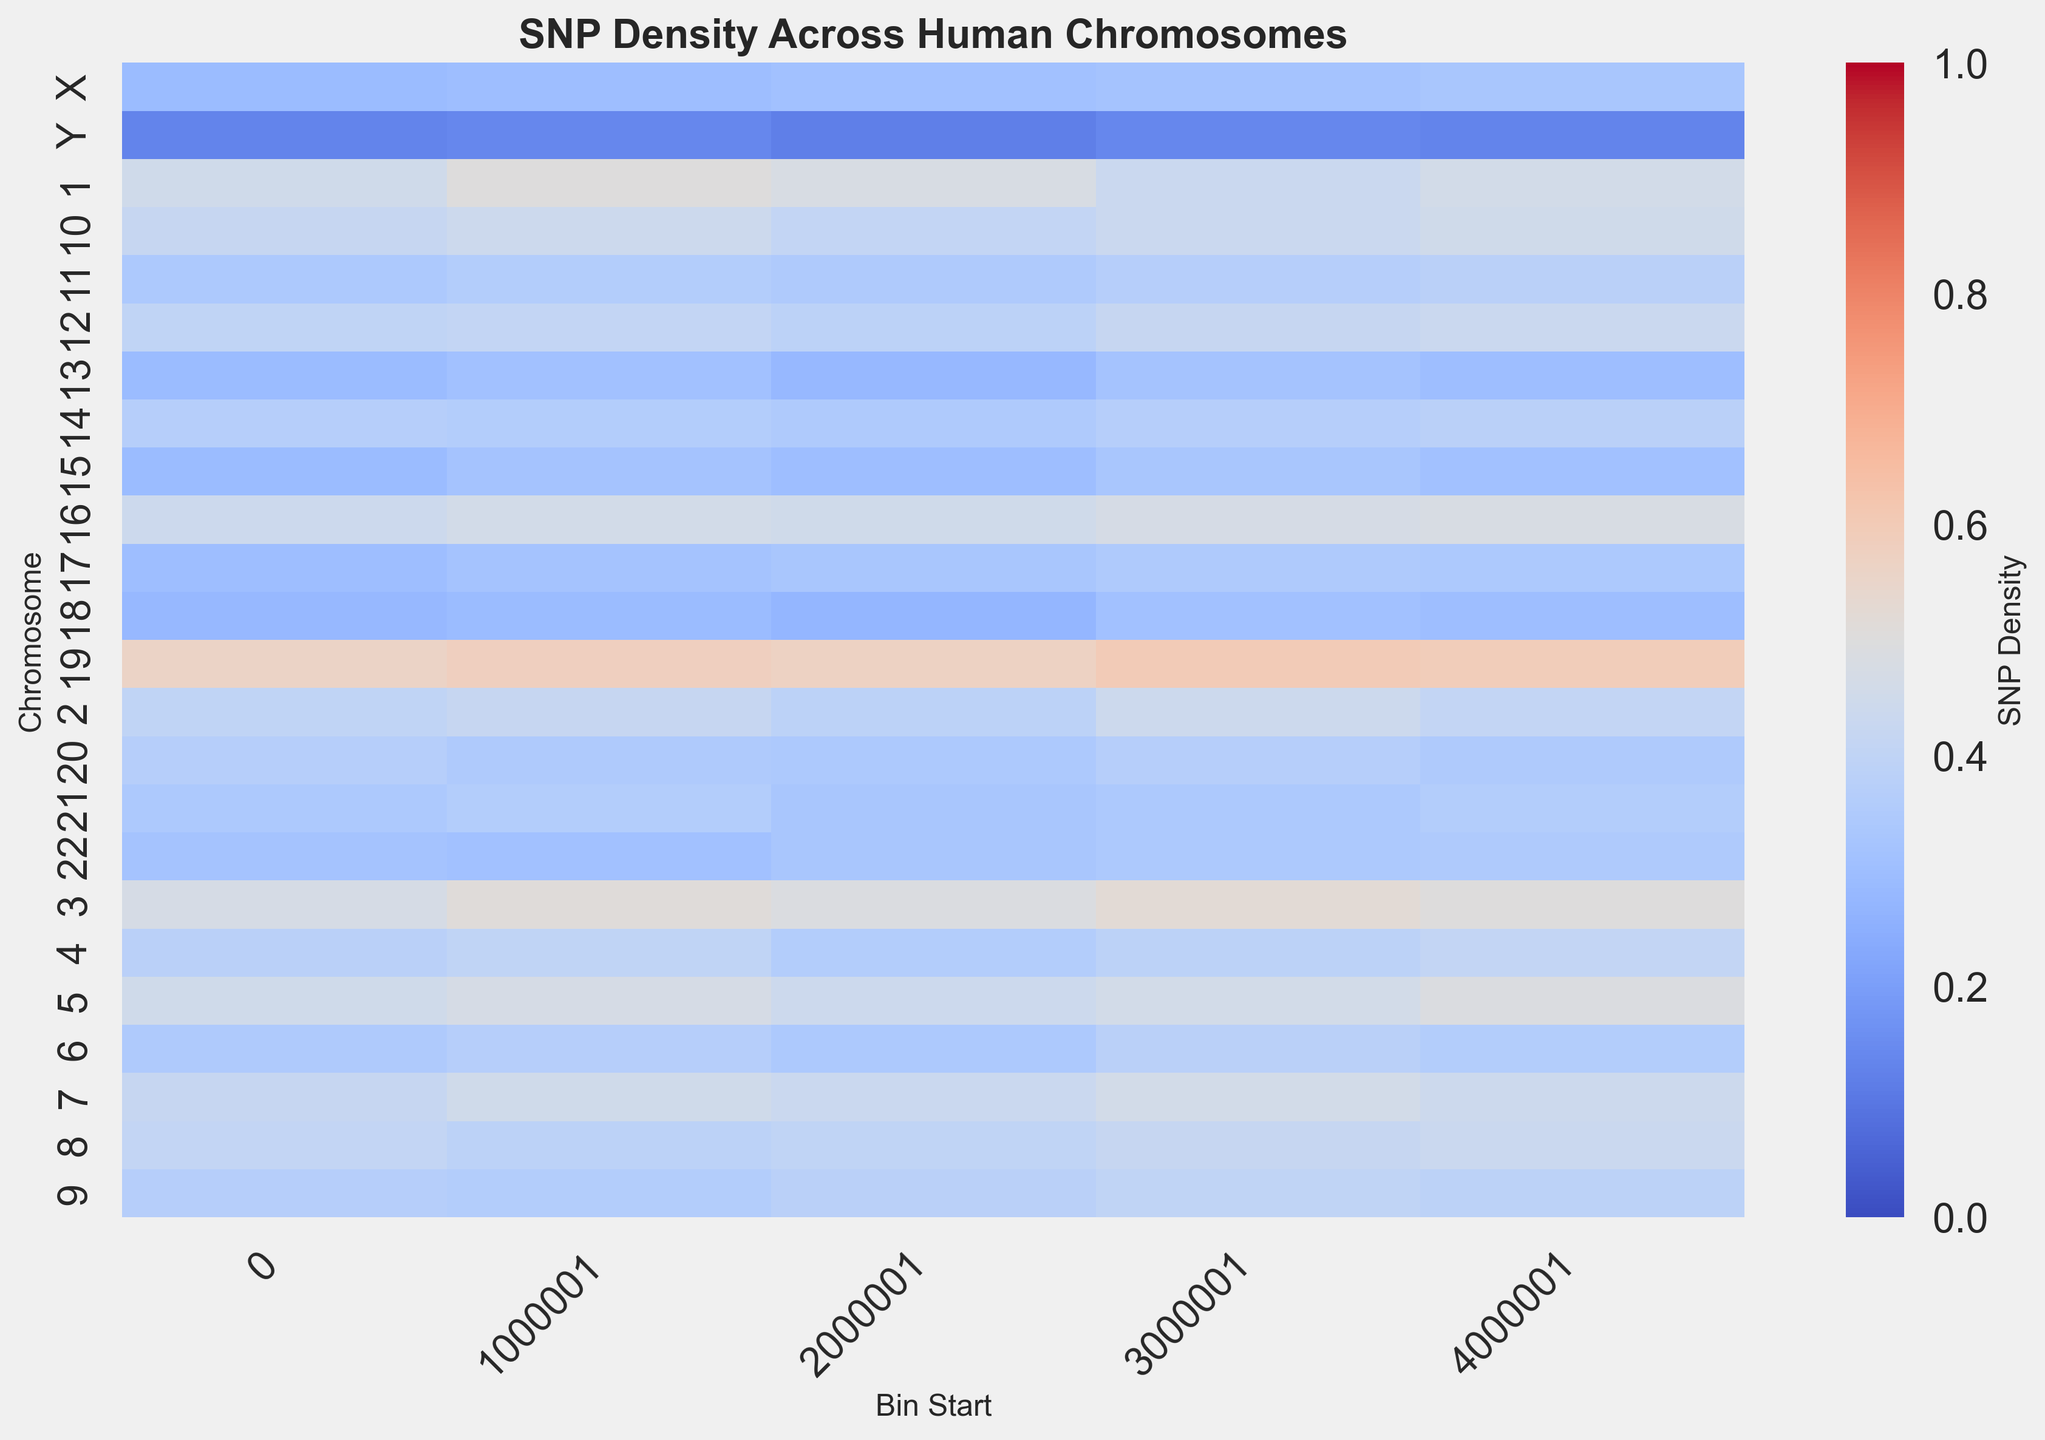Which chromosome has the highest SNP density in any bin? By examining the heatmap, the highest SNP density is indicated by the darkest red color. Chromosome 19 shows the highest density in multiple bins.
Answer: Chromosome 19 Which bin range on chromosome 1 has the highest SNP density? Comparing the intensity of red for each bin on chromosome 1, the bin from 1000001 to 2000000 shows the darkest red, indicating the highest SNP density.
Answer: 1000001 to 2000000 What is the SNP density difference between the highest and lowest bins on chromosome 3? The highest and lowest SNP density values on chromosome 3 are 0.52 and 0.47 respectively. The difference is calculated as 0.52 - 0.47.
Answer: 0.05 Which region has a higher SNP density, the last bin of chromosome 5 or the first bin of chromosome 10? By comparing the colors, the last bin of chromosome 5 (dark red) has a higher SNP density than the first bin of chromosome 10 (light red).
Answer: Last bin of chromosome 5 Which chromosomes have bins with an SNP density below 0.3? The bins with densities below 0.3 are represented in dark blue. Chromosomes 13, 15, 18, and Y have such bins.
Answer: 13, 15, 18, Y What is the average SNP density of the first bins of chromosomes 1, 2, and 19? The SNP densities for the first bins are 0.45 (chromosome 1), 0.40 (chromosome 2), and 0.56 (chromosome 19). The average is calculated as (0.45 + 0.40 + 0.56) / 3.
Answer: 0.47 How does the SNP density in the middle bins of chromosome 4 compare to those of chromosome 8? The middle bins (2000001 to 3000000) of chromosome 4 show a density of 0.36, while chromosome 8 also shows a density around 0.40. Thus, chromosome 8 has a slightly higher SNP density.
Answer: Chromosome 8 Which chromosome has the least variation in SNP density across its bins? Chromosome Y, with densities around 0.12 to 0.14, shows the least color variation (dark blue shades).
Answer: Chromosome Y In which chromosome and bin range combinations does the SNP density consistently increase? Consistent increase in density is indicated by a gradual color change from blue to red. Chromosome 19 shows a consistent SNP density increase across its bins.
Answer: Chromosome 19 